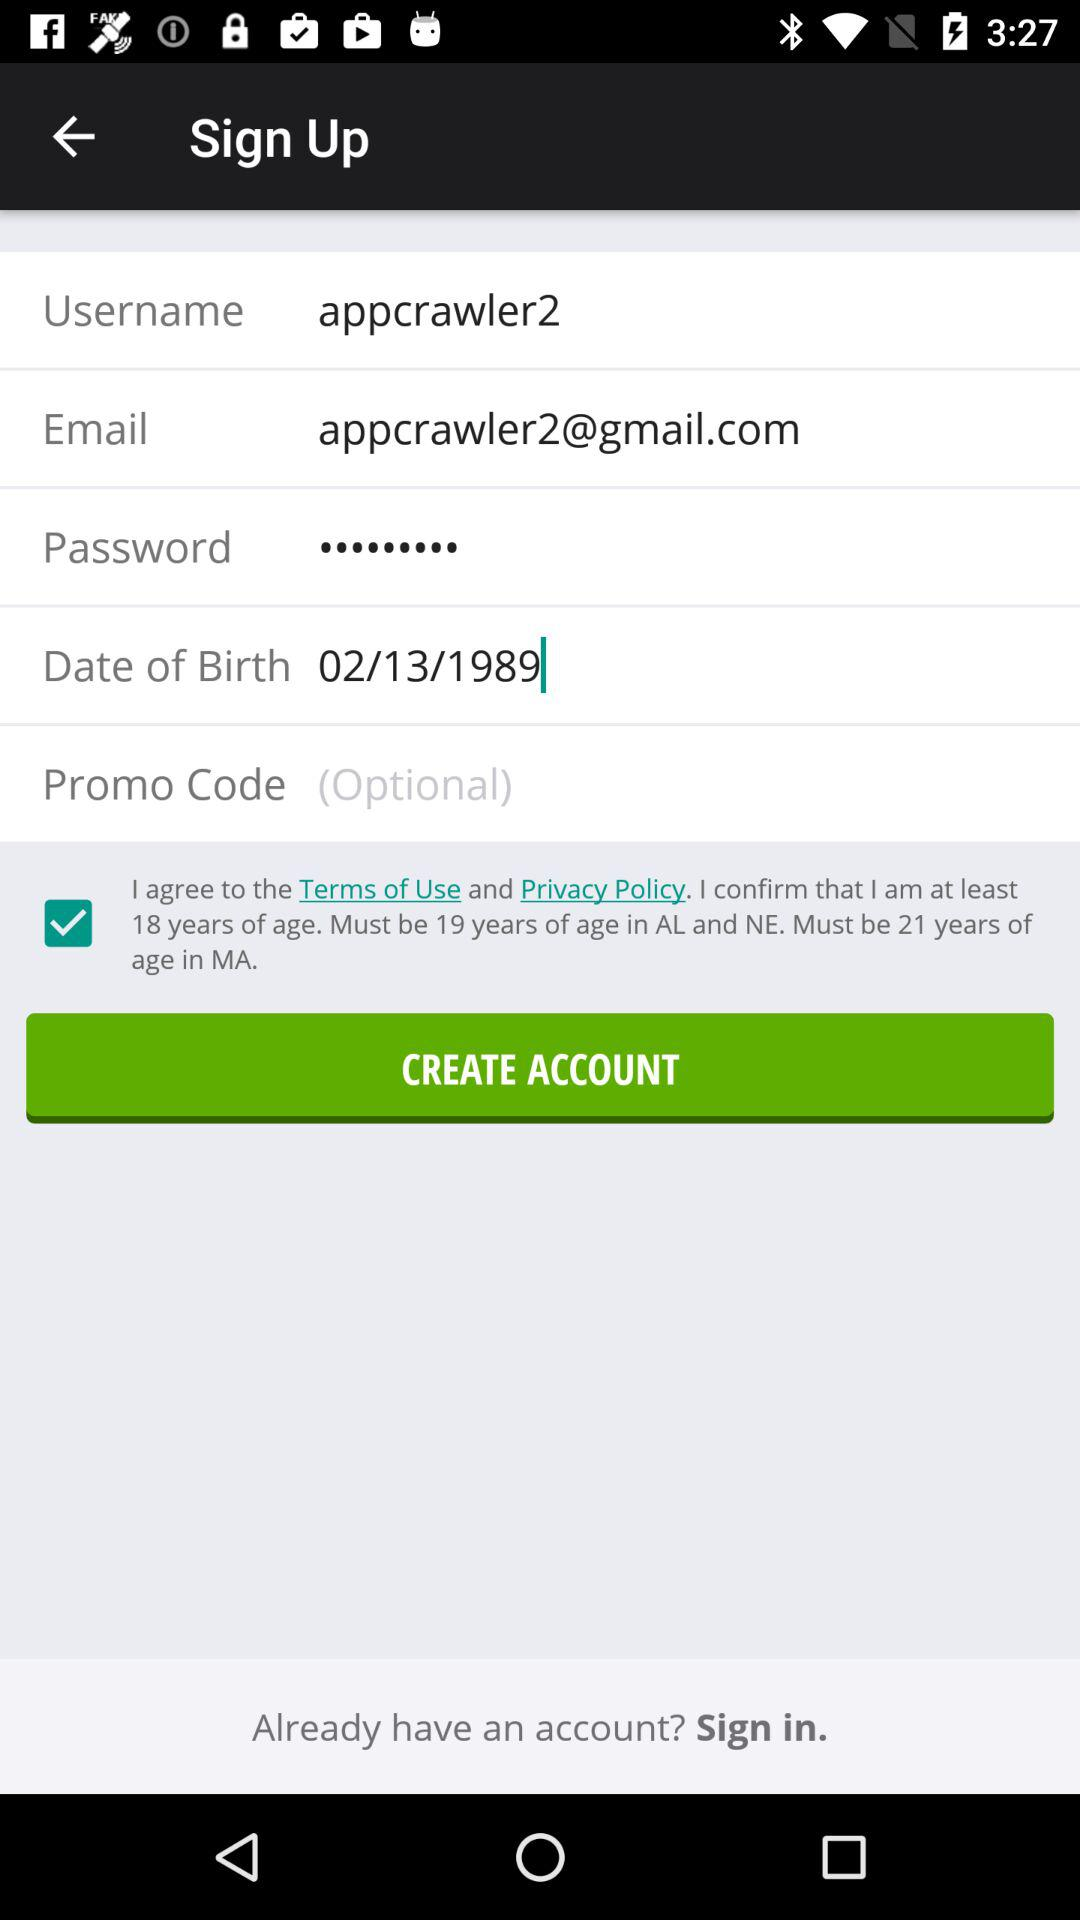What is the given email address? The email address is appcrawler2@gmail.com. 